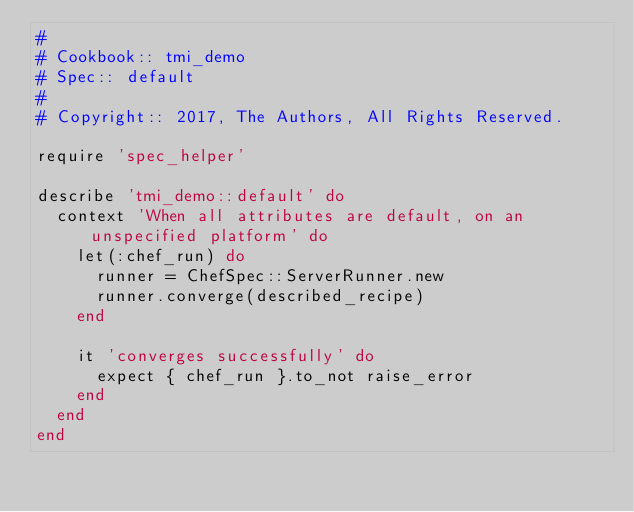Convert code to text. <code><loc_0><loc_0><loc_500><loc_500><_Ruby_>#
# Cookbook:: tmi_demo
# Spec:: default
#
# Copyright:: 2017, The Authors, All Rights Reserved.

require 'spec_helper'

describe 'tmi_demo::default' do
  context 'When all attributes are default, on an unspecified platform' do
    let(:chef_run) do
      runner = ChefSpec::ServerRunner.new
      runner.converge(described_recipe)
    end

    it 'converges successfully' do
      expect { chef_run }.to_not raise_error
    end
  end
end
</code> 